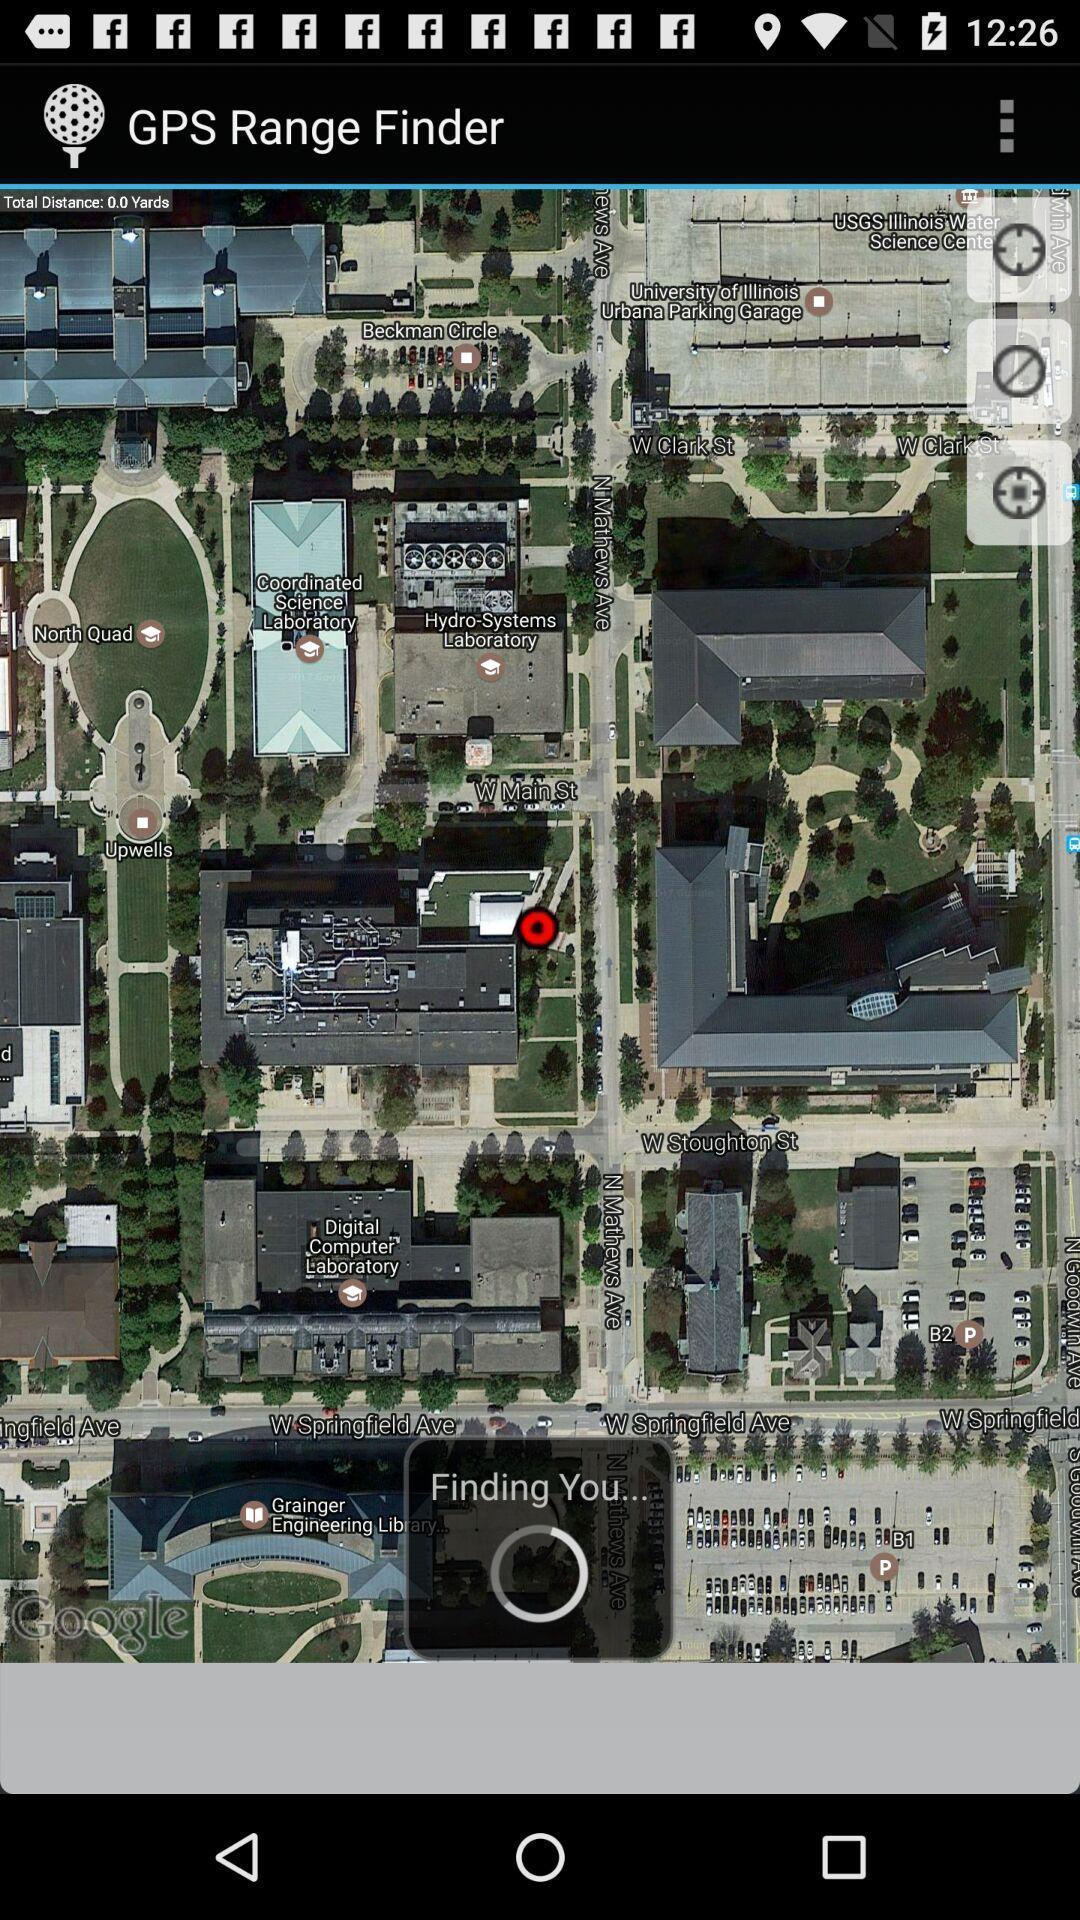Please provide a description for this image. Top view of a location is displaying in tracking app. 